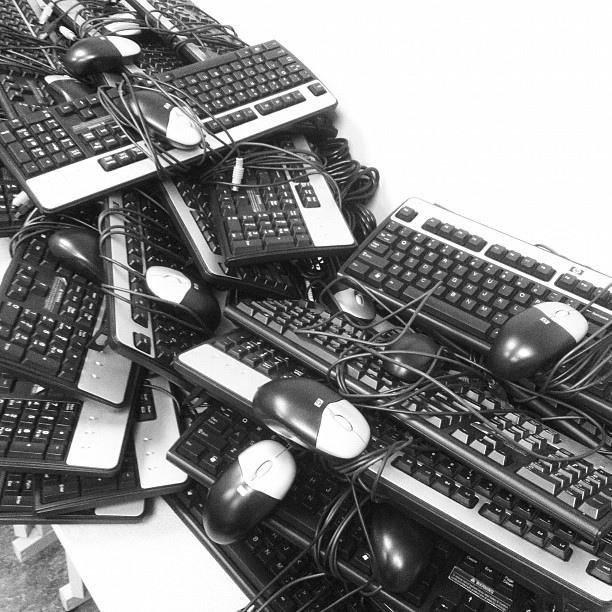Are all the keyboards the same?
Short answer required. Yes. How many computer mouse are in the photo?
Concise answer only. 10. Do these keyboards work?
Be succinct. Yes. 